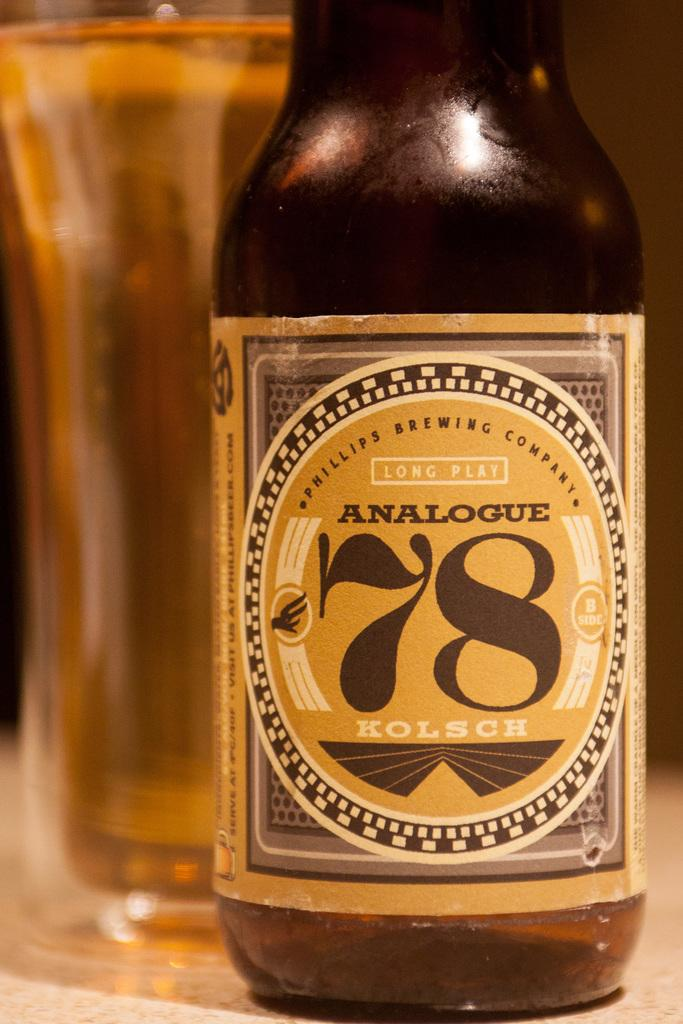Provide a one-sentence caption for the provided image. Analogue Kolsch bottle of long plat beer by a glass. 